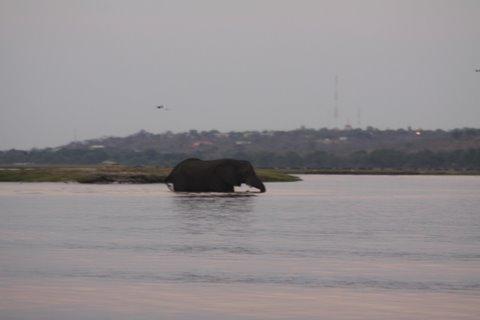What animal is this?
Short answer required. Elephant. Where is the elephant?
Concise answer only. Water. Is the elephant in the city?
Short answer required. No. 